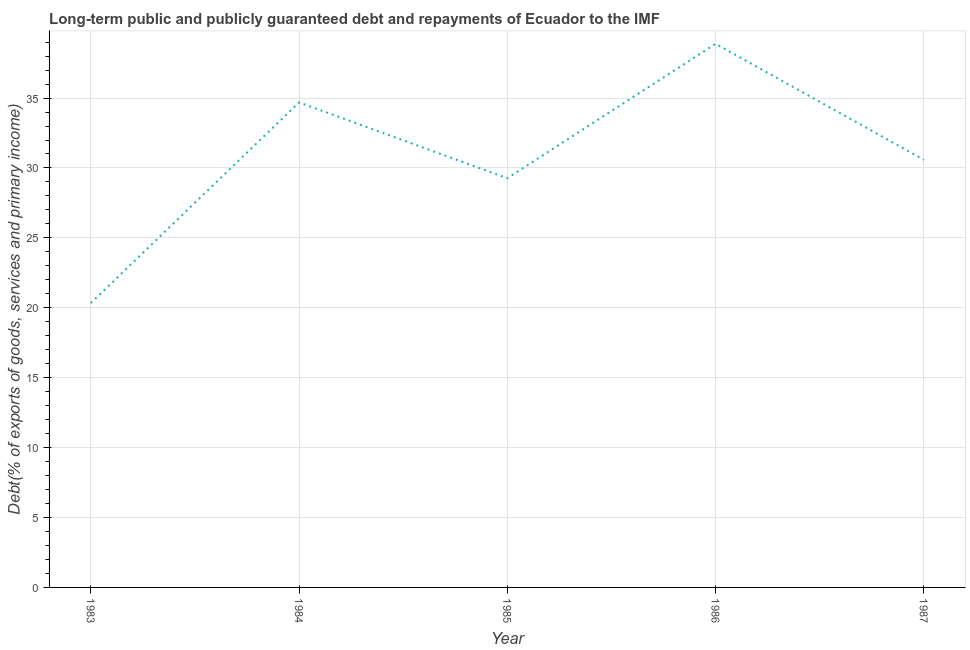What is the debt service in 1986?
Provide a short and direct response. 38.88. Across all years, what is the maximum debt service?
Provide a succinct answer. 38.88. Across all years, what is the minimum debt service?
Keep it short and to the point. 20.34. In which year was the debt service maximum?
Your answer should be compact. 1986. What is the sum of the debt service?
Provide a succinct answer. 153.76. What is the difference between the debt service in 1983 and 1986?
Provide a short and direct response. -18.54. What is the average debt service per year?
Ensure brevity in your answer.  30.75. What is the median debt service?
Make the answer very short. 30.59. In how many years, is the debt service greater than 20 %?
Ensure brevity in your answer.  5. Do a majority of the years between 1984 and 1985 (inclusive) have debt service greater than 6 %?
Offer a very short reply. Yes. What is the ratio of the debt service in 1983 to that in 1986?
Make the answer very short. 0.52. Is the debt service in 1986 less than that in 1987?
Provide a succinct answer. No. What is the difference between the highest and the second highest debt service?
Keep it short and to the point. 4.19. What is the difference between the highest and the lowest debt service?
Keep it short and to the point. 18.54. Does the debt service monotonically increase over the years?
Your answer should be very brief. No. How many lines are there?
Provide a short and direct response. 1. How many years are there in the graph?
Your answer should be compact. 5. What is the difference between two consecutive major ticks on the Y-axis?
Give a very brief answer. 5. Are the values on the major ticks of Y-axis written in scientific E-notation?
Keep it short and to the point. No. Does the graph contain any zero values?
Provide a succinct answer. No. What is the title of the graph?
Offer a terse response. Long-term public and publicly guaranteed debt and repayments of Ecuador to the IMF. What is the label or title of the X-axis?
Offer a very short reply. Year. What is the label or title of the Y-axis?
Your answer should be compact. Debt(% of exports of goods, services and primary income). What is the Debt(% of exports of goods, services and primary income) in 1983?
Make the answer very short. 20.34. What is the Debt(% of exports of goods, services and primary income) in 1984?
Ensure brevity in your answer.  34.69. What is the Debt(% of exports of goods, services and primary income) of 1985?
Ensure brevity in your answer.  29.27. What is the Debt(% of exports of goods, services and primary income) of 1986?
Keep it short and to the point. 38.88. What is the Debt(% of exports of goods, services and primary income) of 1987?
Offer a very short reply. 30.59. What is the difference between the Debt(% of exports of goods, services and primary income) in 1983 and 1984?
Give a very brief answer. -14.35. What is the difference between the Debt(% of exports of goods, services and primary income) in 1983 and 1985?
Your response must be concise. -8.93. What is the difference between the Debt(% of exports of goods, services and primary income) in 1983 and 1986?
Your answer should be very brief. -18.54. What is the difference between the Debt(% of exports of goods, services and primary income) in 1983 and 1987?
Provide a short and direct response. -10.25. What is the difference between the Debt(% of exports of goods, services and primary income) in 1984 and 1985?
Your response must be concise. 5.42. What is the difference between the Debt(% of exports of goods, services and primary income) in 1984 and 1986?
Provide a short and direct response. -4.19. What is the difference between the Debt(% of exports of goods, services and primary income) in 1984 and 1987?
Keep it short and to the point. 4.1. What is the difference between the Debt(% of exports of goods, services and primary income) in 1985 and 1986?
Provide a short and direct response. -9.61. What is the difference between the Debt(% of exports of goods, services and primary income) in 1985 and 1987?
Your answer should be compact. -1.32. What is the difference between the Debt(% of exports of goods, services and primary income) in 1986 and 1987?
Ensure brevity in your answer.  8.29. What is the ratio of the Debt(% of exports of goods, services and primary income) in 1983 to that in 1984?
Provide a short and direct response. 0.59. What is the ratio of the Debt(% of exports of goods, services and primary income) in 1983 to that in 1985?
Ensure brevity in your answer.  0.69. What is the ratio of the Debt(% of exports of goods, services and primary income) in 1983 to that in 1986?
Ensure brevity in your answer.  0.52. What is the ratio of the Debt(% of exports of goods, services and primary income) in 1983 to that in 1987?
Your answer should be very brief. 0.67. What is the ratio of the Debt(% of exports of goods, services and primary income) in 1984 to that in 1985?
Give a very brief answer. 1.19. What is the ratio of the Debt(% of exports of goods, services and primary income) in 1984 to that in 1986?
Provide a succinct answer. 0.89. What is the ratio of the Debt(% of exports of goods, services and primary income) in 1984 to that in 1987?
Your answer should be very brief. 1.13. What is the ratio of the Debt(% of exports of goods, services and primary income) in 1985 to that in 1986?
Offer a very short reply. 0.75. What is the ratio of the Debt(% of exports of goods, services and primary income) in 1986 to that in 1987?
Your answer should be compact. 1.27. 